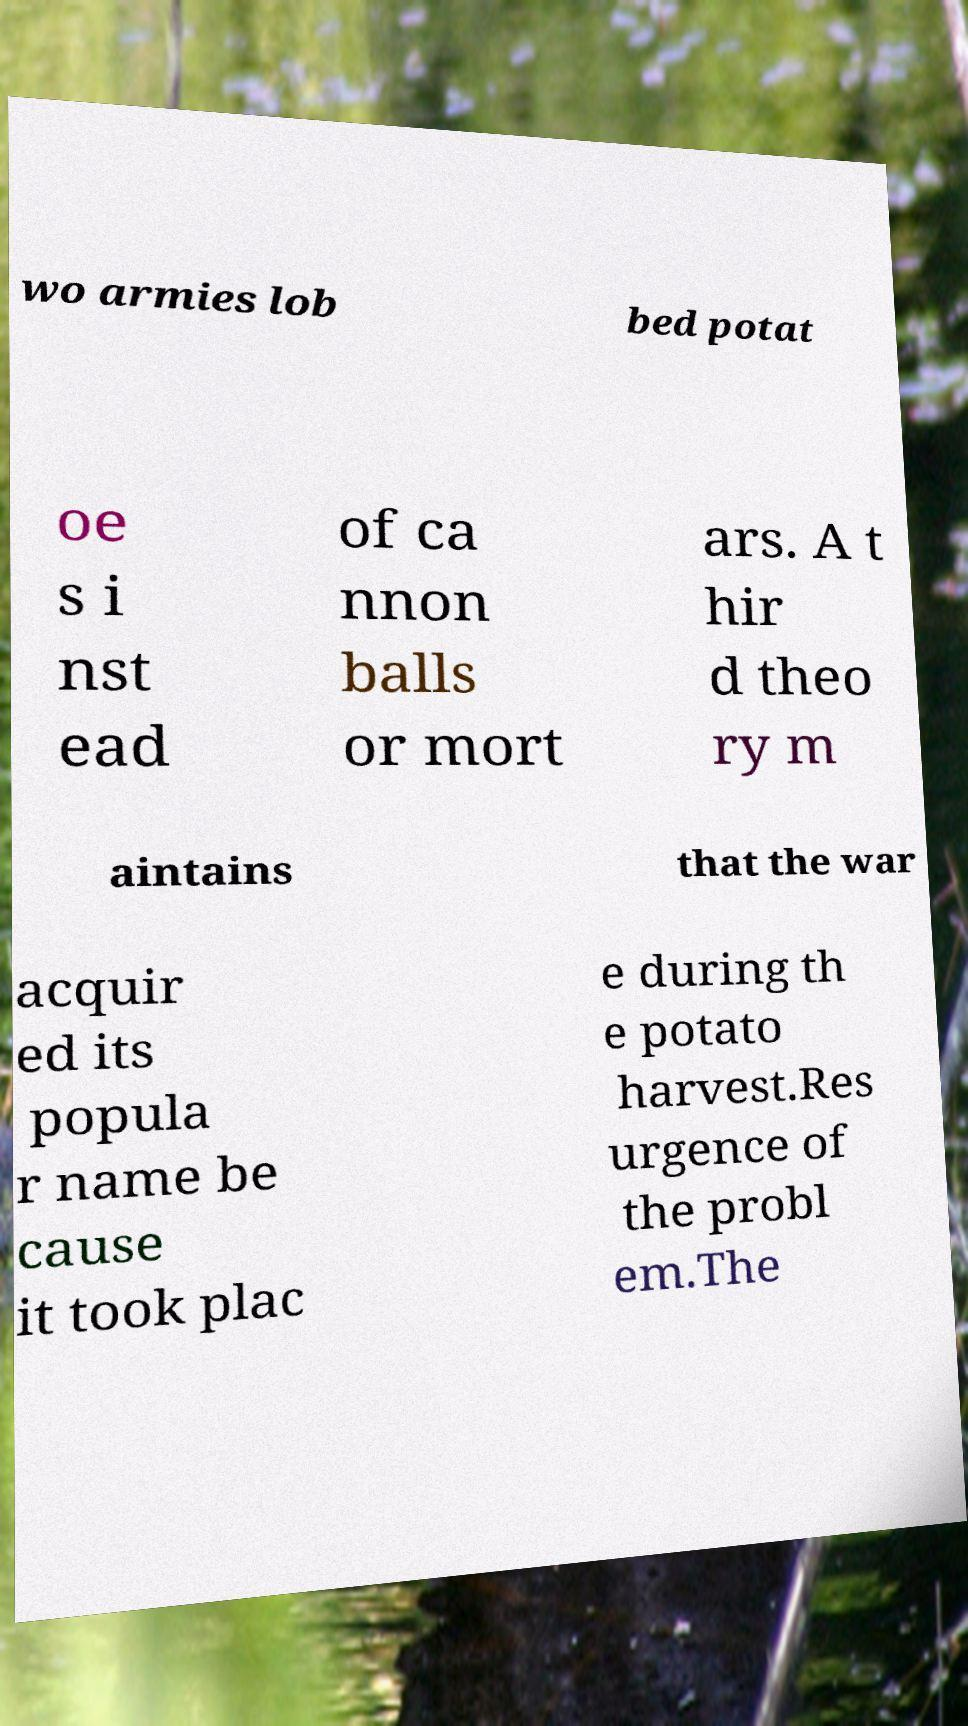Please identify and transcribe the text found in this image. wo armies lob bed potat oe s i nst ead of ca nnon balls or mort ars. A t hir d theo ry m aintains that the war acquir ed its popula r name be cause it took plac e during th e potato harvest.Res urgence of the probl em.The 